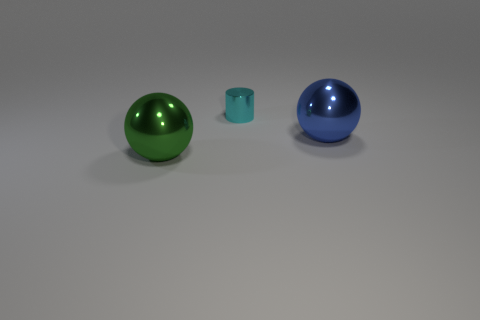There is a blue sphere on the right side of the cylinder; are there any small cylinders on the right side of it?
Provide a succinct answer. No. Is the sphere behind the large green metallic ball made of the same material as the big green ball?
Offer a terse response. Yes. What number of other objects are there of the same color as the tiny metallic cylinder?
Keep it short and to the point. 0. There is a ball that is behind the green metal thing in front of the small thing; what is its size?
Your response must be concise. Large. Are the sphere in front of the blue metallic thing and the sphere behind the green metal thing made of the same material?
Provide a short and direct response. Yes. Is the color of the ball to the left of the tiny cyan metal thing the same as the small metal thing?
Keep it short and to the point. No. How many blue metallic things are behind the large green sphere?
Your answer should be very brief. 1. Are the blue object and the tiny cyan cylinder that is on the right side of the green metal thing made of the same material?
Your answer should be very brief. Yes. What is the size of the blue object that is the same material as the tiny cyan cylinder?
Your answer should be compact. Large. Is the number of small shiny things to the left of the metal cylinder greater than the number of cyan cylinders on the left side of the green object?
Offer a terse response. No. 